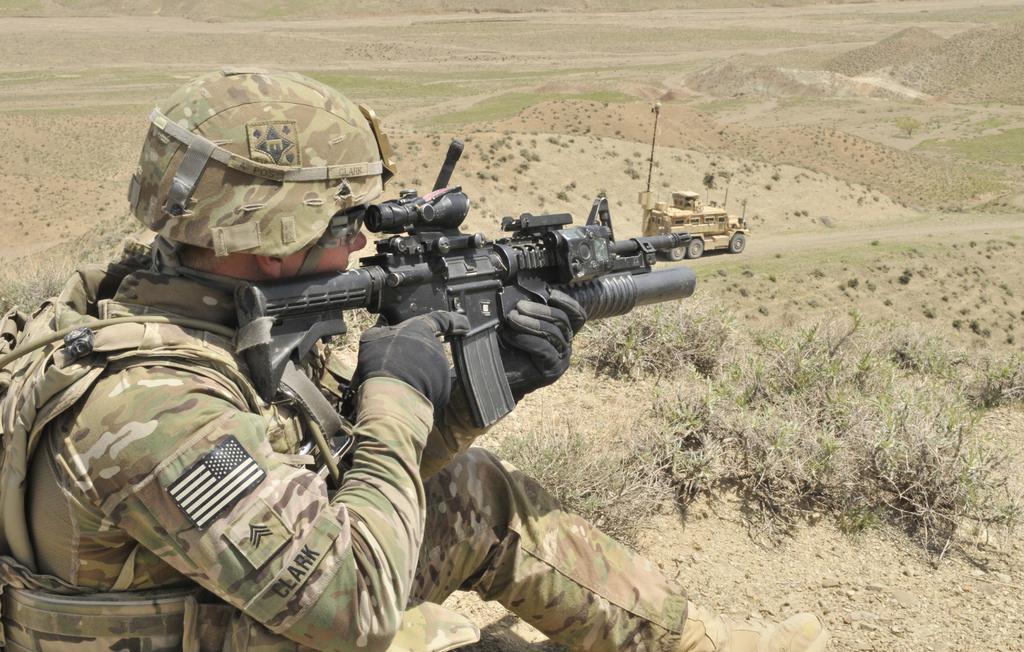How would you summarize this image in a sentence or two? This image consists of a man, who is holding a gun. He is wearing military dress. There is a vehicle in the middle. There is grass in the middle. 